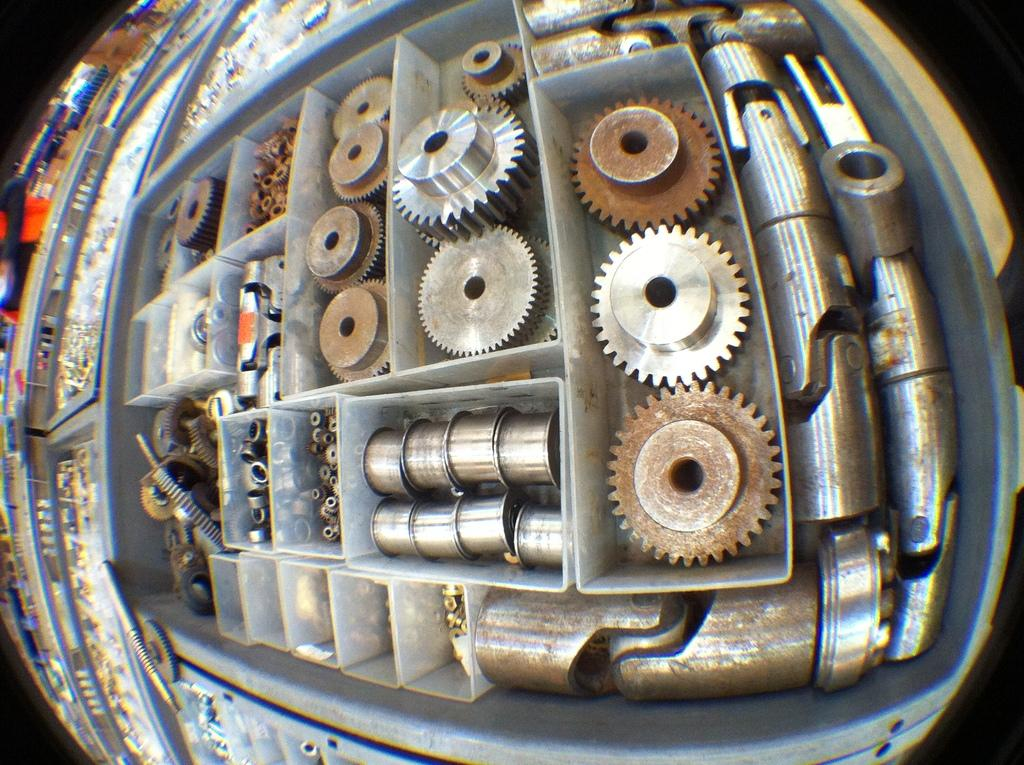What is the main subject of the image? The main subject of the image is a zoomed-in view of mechanical parts. How are the mechanical parts arranged in the image? The mechanical parts are arranged on a shelf. What type of current is flowing through the mechanical parts in the image? There is no indication of any current flowing through the mechanical parts in the image, as it is a static, zoomed-in view of the parts. 